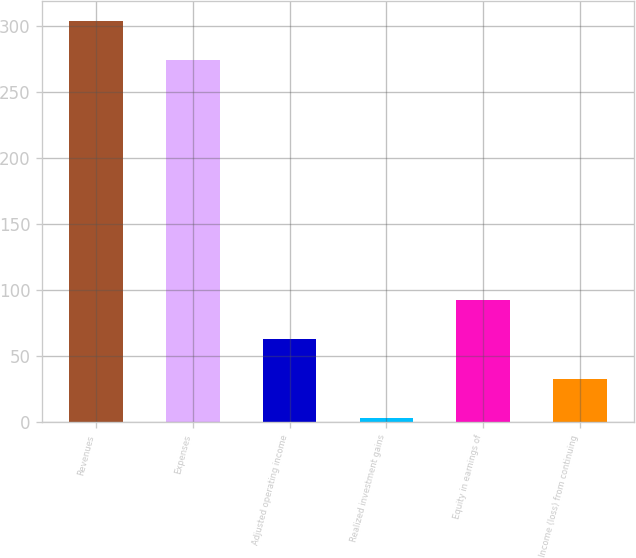Convert chart to OTSL. <chart><loc_0><loc_0><loc_500><loc_500><bar_chart><fcel>Revenues<fcel>Expenses<fcel>Adjusted operating income<fcel>Realized investment gains<fcel>Equity in earnings of<fcel>Income (loss) from continuing<nl><fcel>303.8<fcel>274<fcel>62.6<fcel>3<fcel>92.4<fcel>32.8<nl></chart> 